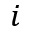<formula> <loc_0><loc_0><loc_500><loc_500>i</formula> 